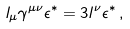<formula> <loc_0><loc_0><loc_500><loc_500>l _ { \mu } \gamma ^ { \mu \nu } \epsilon ^ { * } = 3 l ^ { \nu } \epsilon ^ { * } \, ,</formula> 